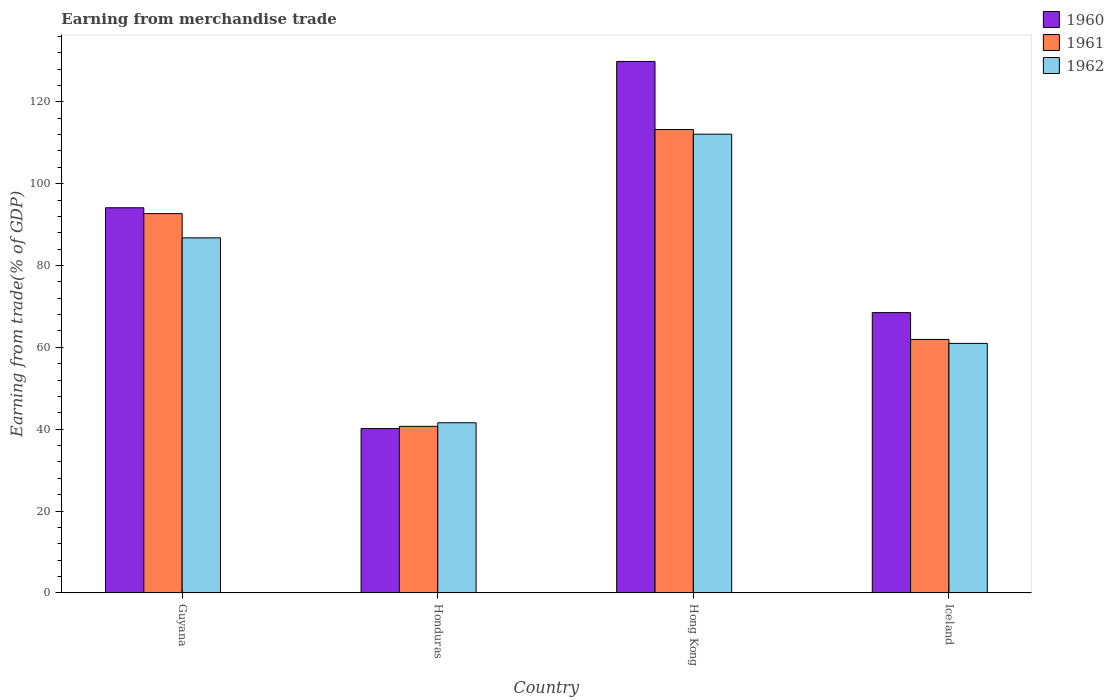How many groups of bars are there?
Offer a very short reply. 4. Are the number of bars on each tick of the X-axis equal?
Your response must be concise. Yes. What is the label of the 2nd group of bars from the left?
Offer a very short reply. Honduras. In how many cases, is the number of bars for a given country not equal to the number of legend labels?
Your response must be concise. 0. What is the earnings from trade in 1960 in Iceland?
Make the answer very short. 68.49. Across all countries, what is the maximum earnings from trade in 1962?
Provide a short and direct response. 112.08. Across all countries, what is the minimum earnings from trade in 1960?
Make the answer very short. 40.16. In which country was the earnings from trade in 1961 maximum?
Provide a succinct answer. Hong Kong. In which country was the earnings from trade in 1960 minimum?
Your response must be concise. Honduras. What is the total earnings from trade in 1960 in the graph?
Your response must be concise. 332.6. What is the difference between the earnings from trade in 1960 in Hong Kong and that in Iceland?
Your answer should be very brief. 61.35. What is the difference between the earnings from trade in 1961 in Iceland and the earnings from trade in 1962 in Guyana?
Offer a very short reply. -24.82. What is the average earnings from trade in 1961 per country?
Your answer should be compact. 77.13. What is the difference between the earnings from trade of/in 1960 and earnings from trade of/in 1962 in Guyana?
Provide a short and direct response. 7.35. In how many countries, is the earnings from trade in 1962 greater than 48 %?
Ensure brevity in your answer.  3. What is the ratio of the earnings from trade in 1961 in Hong Kong to that in Iceland?
Provide a short and direct response. 1.83. Is the difference between the earnings from trade in 1960 in Guyana and Hong Kong greater than the difference between the earnings from trade in 1962 in Guyana and Hong Kong?
Ensure brevity in your answer.  No. What is the difference between the highest and the second highest earnings from trade in 1962?
Your answer should be very brief. 51.11. What is the difference between the highest and the lowest earnings from trade in 1961?
Provide a short and direct response. 72.51. In how many countries, is the earnings from trade in 1960 greater than the average earnings from trade in 1960 taken over all countries?
Provide a short and direct response. 2. Is the sum of the earnings from trade in 1962 in Guyana and Hong Kong greater than the maximum earnings from trade in 1961 across all countries?
Your response must be concise. Yes. What does the 2nd bar from the right in Hong Kong represents?
Provide a succinct answer. 1961. Are all the bars in the graph horizontal?
Offer a very short reply. No. How many countries are there in the graph?
Ensure brevity in your answer.  4. What is the difference between two consecutive major ticks on the Y-axis?
Keep it short and to the point. 20. How many legend labels are there?
Provide a succinct answer. 3. How are the legend labels stacked?
Your response must be concise. Vertical. What is the title of the graph?
Provide a short and direct response. Earning from merchandise trade. Does "2008" appear as one of the legend labels in the graph?
Ensure brevity in your answer.  No. What is the label or title of the Y-axis?
Your response must be concise. Earning from trade(% of GDP). What is the Earning from trade(% of GDP) in 1960 in Guyana?
Your answer should be very brief. 94.1. What is the Earning from trade(% of GDP) in 1961 in Guyana?
Offer a very short reply. 92.67. What is the Earning from trade(% of GDP) in 1962 in Guyana?
Provide a short and direct response. 86.75. What is the Earning from trade(% of GDP) in 1960 in Honduras?
Keep it short and to the point. 40.16. What is the Earning from trade(% of GDP) in 1961 in Honduras?
Your answer should be compact. 40.71. What is the Earning from trade(% of GDP) of 1962 in Honduras?
Offer a very short reply. 41.59. What is the Earning from trade(% of GDP) in 1960 in Hong Kong?
Ensure brevity in your answer.  129.85. What is the Earning from trade(% of GDP) in 1961 in Hong Kong?
Ensure brevity in your answer.  113.21. What is the Earning from trade(% of GDP) of 1962 in Hong Kong?
Provide a succinct answer. 112.08. What is the Earning from trade(% of GDP) of 1960 in Iceland?
Provide a short and direct response. 68.49. What is the Earning from trade(% of GDP) in 1961 in Iceland?
Your answer should be compact. 61.93. What is the Earning from trade(% of GDP) of 1962 in Iceland?
Provide a short and direct response. 60.97. Across all countries, what is the maximum Earning from trade(% of GDP) in 1960?
Provide a succinct answer. 129.85. Across all countries, what is the maximum Earning from trade(% of GDP) of 1961?
Your answer should be very brief. 113.21. Across all countries, what is the maximum Earning from trade(% of GDP) in 1962?
Offer a terse response. 112.08. Across all countries, what is the minimum Earning from trade(% of GDP) of 1960?
Make the answer very short. 40.16. Across all countries, what is the minimum Earning from trade(% of GDP) of 1961?
Give a very brief answer. 40.71. Across all countries, what is the minimum Earning from trade(% of GDP) of 1962?
Your answer should be very brief. 41.59. What is the total Earning from trade(% of GDP) in 1960 in the graph?
Make the answer very short. 332.6. What is the total Earning from trade(% of GDP) in 1961 in the graph?
Make the answer very short. 308.52. What is the total Earning from trade(% of GDP) in 1962 in the graph?
Your response must be concise. 301.39. What is the difference between the Earning from trade(% of GDP) of 1960 in Guyana and that in Honduras?
Provide a succinct answer. 53.94. What is the difference between the Earning from trade(% of GDP) of 1961 in Guyana and that in Honduras?
Provide a succinct answer. 51.96. What is the difference between the Earning from trade(% of GDP) in 1962 in Guyana and that in Honduras?
Give a very brief answer. 45.17. What is the difference between the Earning from trade(% of GDP) in 1960 in Guyana and that in Hong Kong?
Provide a succinct answer. -35.74. What is the difference between the Earning from trade(% of GDP) in 1961 in Guyana and that in Hong Kong?
Offer a terse response. -20.54. What is the difference between the Earning from trade(% of GDP) in 1962 in Guyana and that in Hong Kong?
Your answer should be compact. -25.33. What is the difference between the Earning from trade(% of GDP) of 1960 in Guyana and that in Iceland?
Give a very brief answer. 25.61. What is the difference between the Earning from trade(% of GDP) of 1961 in Guyana and that in Iceland?
Keep it short and to the point. 30.74. What is the difference between the Earning from trade(% of GDP) of 1962 in Guyana and that in Iceland?
Offer a very short reply. 25.78. What is the difference between the Earning from trade(% of GDP) in 1960 in Honduras and that in Hong Kong?
Ensure brevity in your answer.  -89.68. What is the difference between the Earning from trade(% of GDP) in 1961 in Honduras and that in Hong Kong?
Give a very brief answer. -72.51. What is the difference between the Earning from trade(% of GDP) of 1962 in Honduras and that in Hong Kong?
Ensure brevity in your answer.  -70.49. What is the difference between the Earning from trade(% of GDP) in 1960 in Honduras and that in Iceland?
Your answer should be compact. -28.33. What is the difference between the Earning from trade(% of GDP) in 1961 in Honduras and that in Iceland?
Provide a succinct answer. -21.23. What is the difference between the Earning from trade(% of GDP) in 1962 in Honduras and that in Iceland?
Give a very brief answer. -19.39. What is the difference between the Earning from trade(% of GDP) of 1960 in Hong Kong and that in Iceland?
Offer a terse response. 61.35. What is the difference between the Earning from trade(% of GDP) in 1961 in Hong Kong and that in Iceland?
Your answer should be very brief. 51.28. What is the difference between the Earning from trade(% of GDP) of 1962 in Hong Kong and that in Iceland?
Offer a terse response. 51.11. What is the difference between the Earning from trade(% of GDP) in 1960 in Guyana and the Earning from trade(% of GDP) in 1961 in Honduras?
Your answer should be very brief. 53.39. What is the difference between the Earning from trade(% of GDP) in 1960 in Guyana and the Earning from trade(% of GDP) in 1962 in Honduras?
Your answer should be compact. 52.52. What is the difference between the Earning from trade(% of GDP) of 1961 in Guyana and the Earning from trade(% of GDP) of 1962 in Honduras?
Keep it short and to the point. 51.09. What is the difference between the Earning from trade(% of GDP) of 1960 in Guyana and the Earning from trade(% of GDP) of 1961 in Hong Kong?
Make the answer very short. -19.11. What is the difference between the Earning from trade(% of GDP) in 1960 in Guyana and the Earning from trade(% of GDP) in 1962 in Hong Kong?
Make the answer very short. -17.98. What is the difference between the Earning from trade(% of GDP) of 1961 in Guyana and the Earning from trade(% of GDP) of 1962 in Hong Kong?
Offer a very short reply. -19.41. What is the difference between the Earning from trade(% of GDP) of 1960 in Guyana and the Earning from trade(% of GDP) of 1961 in Iceland?
Provide a succinct answer. 32.17. What is the difference between the Earning from trade(% of GDP) of 1960 in Guyana and the Earning from trade(% of GDP) of 1962 in Iceland?
Provide a succinct answer. 33.13. What is the difference between the Earning from trade(% of GDP) in 1961 in Guyana and the Earning from trade(% of GDP) in 1962 in Iceland?
Provide a succinct answer. 31.7. What is the difference between the Earning from trade(% of GDP) in 1960 in Honduras and the Earning from trade(% of GDP) in 1961 in Hong Kong?
Your answer should be very brief. -73.05. What is the difference between the Earning from trade(% of GDP) of 1960 in Honduras and the Earning from trade(% of GDP) of 1962 in Hong Kong?
Make the answer very short. -71.92. What is the difference between the Earning from trade(% of GDP) in 1961 in Honduras and the Earning from trade(% of GDP) in 1962 in Hong Kong?
Provide a short and direct response. -71.37. What is the difference between the Earning from trade(% of GDP) of 1960 in Honduras and the Earning from trade(% of GDP) of 1961 in Iceland?
Provide a short and direct response. -21.77. What is the difference between the Earning from trade(% of GDP) of 1960 in Honduras and the Earning from trade(% of GDP) of 1962 in Iceland?
Provide a succinct answer. -20.81. What is the difference between the Earning from trade(% of GDP) in 1961 in Honduras and the Earning from trade(% of GDP) in 1962 in Iceland?
Offer a very short reply. -20.27. What is the difference between the Earning from trade(% of GDP) in 1960 in Hong Kong and the Earning from trade(% of GDP) in 1961 in Iceland?
Offer a terse response. 67.91. What is the difference between the Earning from trade(% of GDP) in 1960 in Hong Kong and the Earning from trade(% of GDP) in 1962 in Iceland?
Provide a short and direct response. 68.87. What is the difference between the Earning from trade(% of GDP) of 1961 in Hong Kong and the Earning from trade(% of GDP) of 1962 in Iceland?
Offer a very short reply. 52.24. What is the average Earning from trade(% of GDP) in 1960 per country?
Your response must be concise. 83.15. What is the average Earning from trade(% of GDP) of 1961 per country?
Your response must be concise. 77.13. What is the average Earning from trade(% of GDP) in 1962 per country?
Offer a terse response. 75.35. What is the difference between the Earning from trade(% of GDP) in 1960 and Earning from trade(% of GDP) in 1961 in Guyana?
Your response must be concise. 1.43. What is the difference between the Earning from trade(% of GDP) of 1960 and Earning from trade(% of GDP) of 1962 in Guyana?
Provide a succinct answer. 7.35. What is the difference between the Earning from trade(% of GDP) of 1961 and Earning from trade(% of GDP) of 1962 in Guyana?
Keep it short and to the point. 5.92. What is the difference between the Earning from trade(% of GDP) in 1960 and Earning from trade(% of GDP) in 1961 in Honduras?
Make the answer very short. -0.55. What is the difference between the Earning from trade(% of GDP) of 1960 and Earning from trade(% of GDP) of 1962 in Honduras?
Make the answer very short. -1.43. What is the difference between the Earning from trade(% of GDP) in 1961 and Earning from trade(% of GDP) in 1962 in Honduras?
Give a very brief answer. -0.88. What is the difference between the Earning from trade(% of GDP) in 1960 and Earning from trade(% of GDP) in 1961 in Hong Kong?
Your answer should be compact. 16.63. What is the difference between the Earning from trade(% of GDP) of 1960 and Earning from trade(% of GDP) of 1962 in Hong Kong?
Offer a very short reply. 17.76. What is the difference between the Earning from trade(% of GDP) of 1961 and Earning from trade(% of GDP) of 1962 in Hong Kong?
Offer a very short reply. 1.13. What is the difference between the Earning from trade(% of GDP) of 1960 and Earning from trade(% of GDP) of 1961 in Iceland?
Keep it short and to the point. 6.56. What is the difference between the Earning from trade(% of GDP) of 1960 and Earning from trade(% of GDP) of 1962 in Iceland?
Make the answer very short. 7.52. What is the difference between the Earning from trade(% of GDP) in 1961 and Earning from trade(% of GDP) in 1962 in Iceland?
Provide a short and direct response. 0.96. What is the ratio of the Earning from trade(% of GDP) in 1960 in Guyana to that in Honduras?
Ensure brevity in your answer.  2.34. What is the ratio of the Earning from trade(% of GDP) in 1961 in Guyana to that in Honduras?
Your answer should be very brief. 2.28. What is the ratio of the Earning from trade(% of GDP) in 1962 in Guyana to that in Honduras?
Give a very brief answer. 2.09. What is the ratio of the Earning from trade(% of GDP) of 1960 in Guyana to that in Hong Kong?
Your answer should be compact. 0.72. What is the ratio of the Earning from trade(% of GDP) of 1961 in Guyana to that in Hong Kong?
Make the answer very short. 0.82. What is the ratio of the Earning from trade(% of GDP) of 1962 in Guyana to that in Hong Kong?
Your answer should be compact. 0.77. What is the ratio of the Earning from trade(% of GDP) in 1960 in Guyana to that in Iceland?
Offer a terse response. 1.37. What is the ratio of the Earning from trade(% of GDP) of 1961 in Guyana to that in Iceland?
Give a very brief answer. 1.5. What is the ratio of the Earning from trade(% of GDP) in 1962 in Guyana to that in Iceland?
Make the answer very short. 1.42. What is the ratio of the Earning from trade(% of GDP) in 1960 in Honduras to that in Hong Kong?
Provide a succinct answer. 0.31. What is the ratio of the Earning from trade(% of GDP) of 1961 in Honduras to that in Hong Kong?
Your answer should be very brief. 0.36. What is the ratio of the Earning from trade(% of GDP) in 1962 in Honduras to that in Hong Kong?
Your response must be concise. 0.37. What is the ratio of the Earning from trade(% of GDP) of 1960 in Honduras to that in Iceland?
Your answer should be compact. 0.59. What is the ratio of the Earning from trade(% of GDP) in 1961 in Honduras to that in Iceland?
Make the answer very short. 0.66. What is the ratio of the Earning from trade(% of GDP) of 1962 in Honduras to that in Iceland?
Your response must be concise. 0.68. What is the ratio of the Earning from trade(% of GDP) in 1960 in Hong Kong to that in Iceland?
Provide a succinct answer. 1.9. What is the ratio of the Earning from trade(% of GDP) of 1961 in Hong Kong to that in Iceland?
Your answer should be very brief. 1.83. What is the ratio of the Earning from trade(% of GDP) in 1962 in Hong Kong to that in Iceland?
Your answer should be very brief. 1.84. What is the difference between the highest and the second highest Earning from trade(% of GDP) of 1960?
Keep it short and to the point. 35.74. What is the difference between the highest and the second highest Earning from trade(% of GDP) in 1961?
Offer a very short reply. 20.54. What is the difference between the highest and the second highest Earning from trade(% of GDP) in 1962?
Offer a very short reply. 25.33. What is the difference between the highest and the lowest Earning from trade(% of GDP) of 1960?
Keep it short and to the point. 89.68. What is the difference between the highest and the lowest Earning from trade(% of GDP) in 1961?
Your answer should be very brief. 72.51. What is the difference between the highest and the lowest Earning from trade(% of GDP) of 1962?
Offer a very short reply. 70.49. 